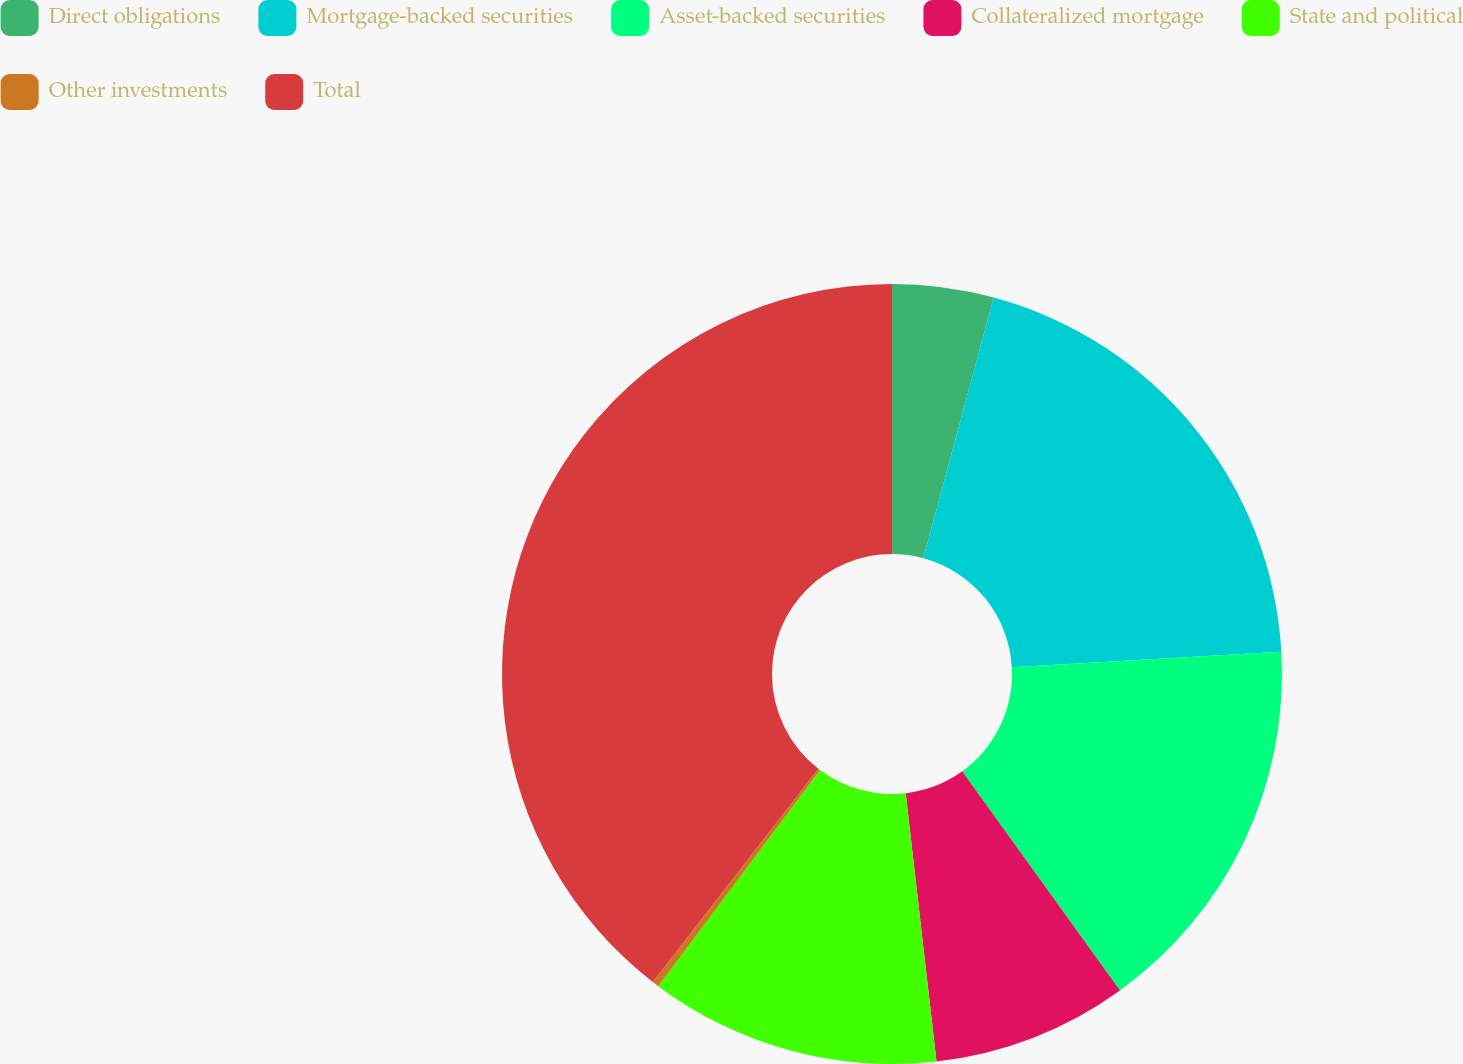Convert chart. <chart><loc_0><loc_0><loc_500><loc_500><pie_chart><fcel>Direct obligations<fcel>Mortgage-backed securities<fcel>Asset-backed securities<fcel>Collateralized mortgage<fcel>State and political<fcel>Other investments<fcel>Total<nl><fcel>4.2%<fcel>19.89%<fcel>15.97%<fcel>8.12%<fcel>12.05%<fcel>0.28%<fcel>39.49%<nl></chart> 